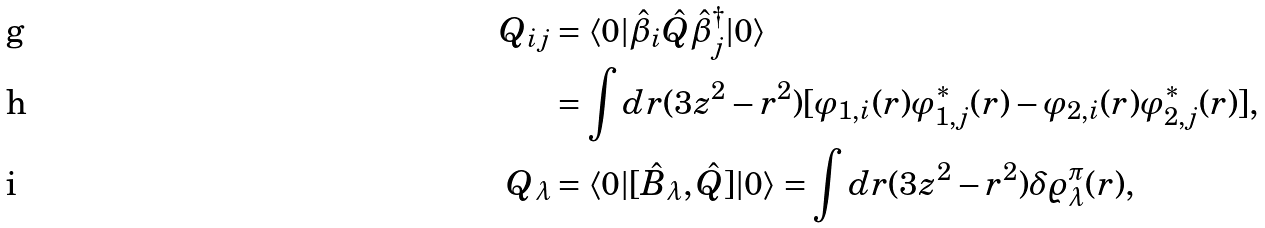<formula> <loc_0><loc_0><loc_500><loc_500>Q _ { i j } & = \langle 0 | \hat { \beta } _ { i } \hat { Q } \hat { \beta } ^ { \dagger } _ { j } | 0 \rangle \\ & = \int d r ( 3 z ^ { 2 } - r ^ { 2 } ) [ \varphi _ { 1 , i } ( r ) \varphi ^ { * } _ { 1 , j } ( r ) - \varphi _ { 2 , i } ( r ) \varphi ^ { * } _ { 2 , j } ( r ) ] , \\ Q _ { \lambda } & = \langle 0 | [ \hat { B } _ { \lambda } , \hat { Q } ] | 0 \rangle = \int d r ( 3 z ^ { 2 } - r ^ { 2 } ) \delta \varrho _ { \lambda } ^ { \pi } ( r ) ,</formula> 